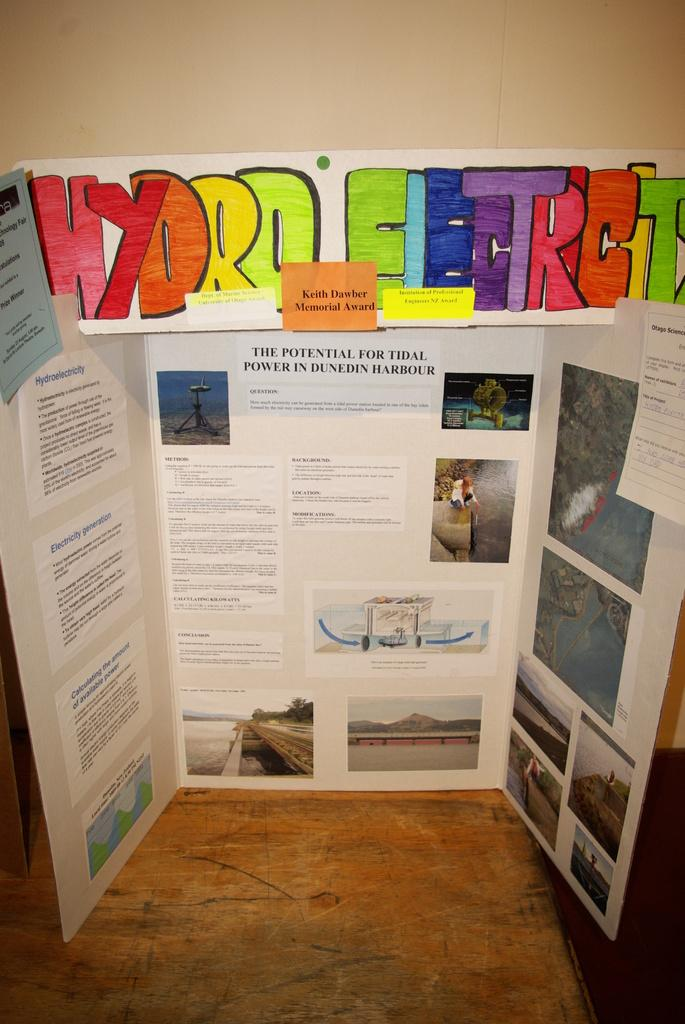What is located on the white sheet in the foreground of the image? There are posters on the white sheet in the foreground of the image. What is the white sheet placed on? The white sheet is placed on a wooden surface. What can be seen at the top of the image? There is a board at the top of the image. What is visible in the background of the image? There is a wall in the background of the image. How does the slip affect the posters on the white sheet in the image? There is no slip present in the image, so it cannot affect the posters on the white sheet. On which side of the wooden surface is the white sheet placed? The provided facts do not specify which side of the wooden surface the white sheet is placed on. 